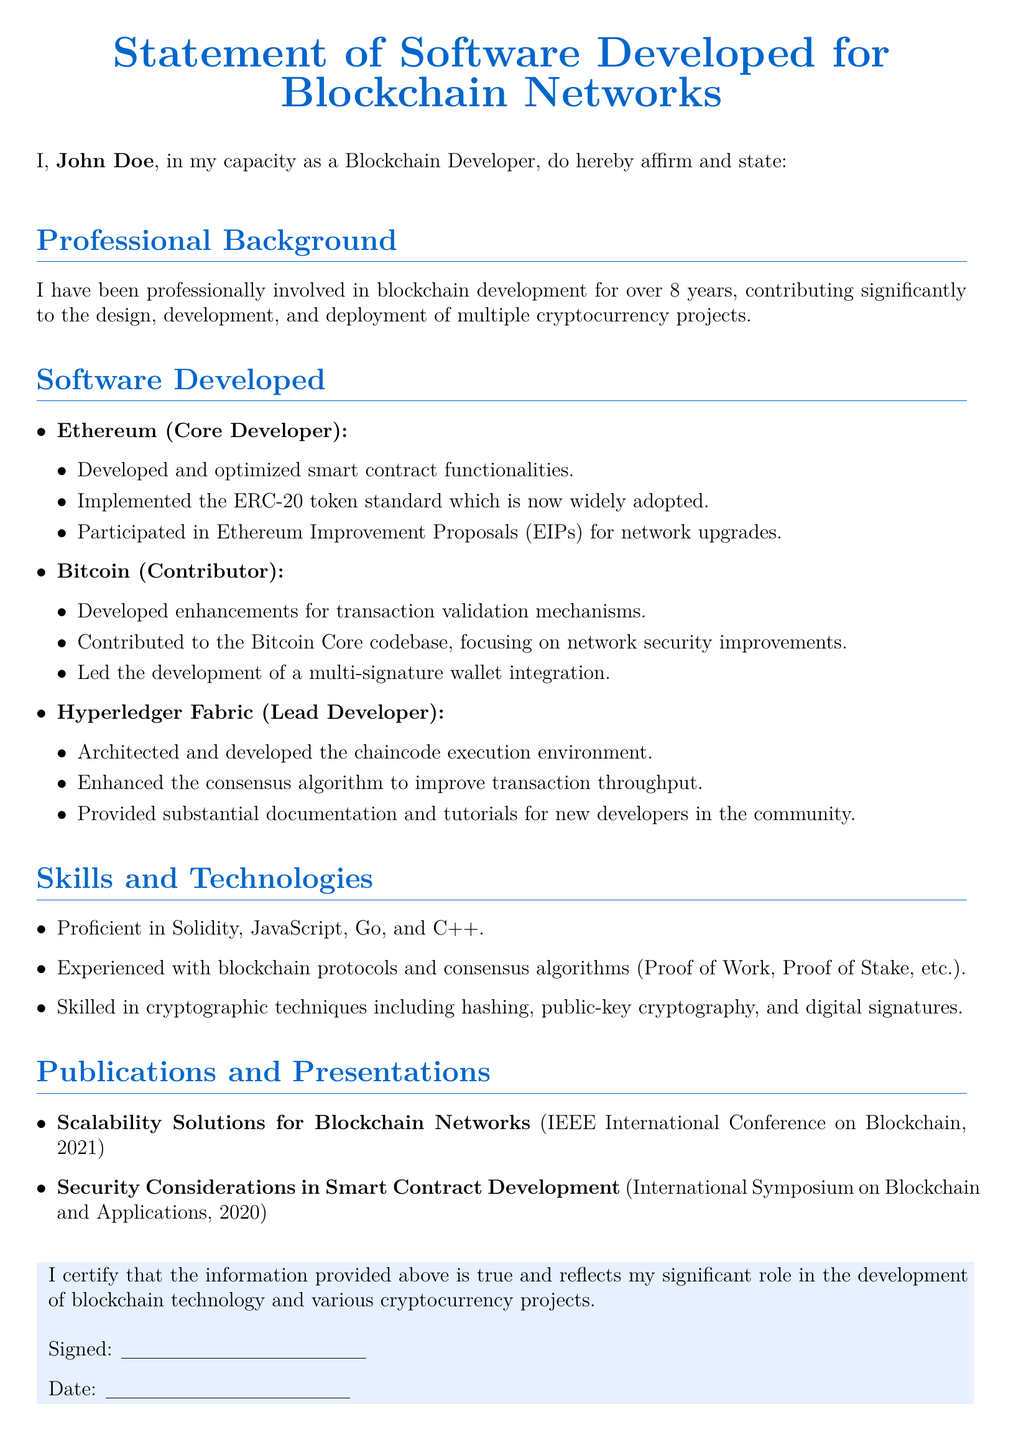What is the name of the person affirming the statement? The person affirming the statement is the individual mentioned at the beginning of the document, which is John Doe.
Answer: John Doe How many years of experience does the author have in blockchain development? The document states that the author has been involved in blockchain development for over 8 years.
Answer: 8 years What cryptocurrency does the author claim to have contributed to as a Core Developer? The document specifies that the author has worked as a Core Developer for Ethereum.
Answer: Ethereum Which consensus algorithm was enhanced by the author in Hyperledger Fabric? The author mentions enhancing the consensus algorithm but does not specify the name in this excerpt. The algorithm could refer to a specific type.
Answer: Consensus algorithm What is one of the programming languages the author is proficient in? The document lists several programming languages, including Solidity, JavaScript, Go, and C++.
Answer: Solidity What is the title of the publication presented at the IEEE International Conference on Blockchain? The document provides the title of the publication as "Scalability Solutions for Blockchain Networks."
Answer: Scalability Solutions for Blockchain Networks What type of documentation did the author provide for new developers? The author mentions providing substantial documentation and tutorials in the community, specifically for newcomers.
Answer: Documentation and tutorials In what year was the paper on security considerations published? The document indicates that the publication regarding security considerations was presented in the year 2020.
Answer: 2020 What does the document declare about the information provided? The document contains a certification statement asserting the truthfulness of the information given.
Answer: True 